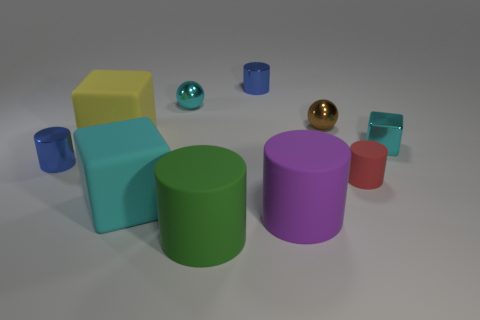Subtract all blue cylinders. How many cylinders are left? 3 Subtract all purple cylinders. How many cylinders are left? 4 Subtract all balls. How many objects are left? 8 Subtract 1 spheres. How many spheres are left? 1 Subtract all big green blocks. Subtract all rubber cubes. How many objects are left? 8 Add 1 small cyan cubes. How many small cyan cubes are left? 2 Add 6 small red matte things. How many small red matte things exist? 7 Subtract 0 brown cylinders. How many objects are left? 10 Subtract all blue cubes. Subtract all blue spheres. How many cubes are left? 3 Subtract all brown cubes. How many brown balls are left? 1 